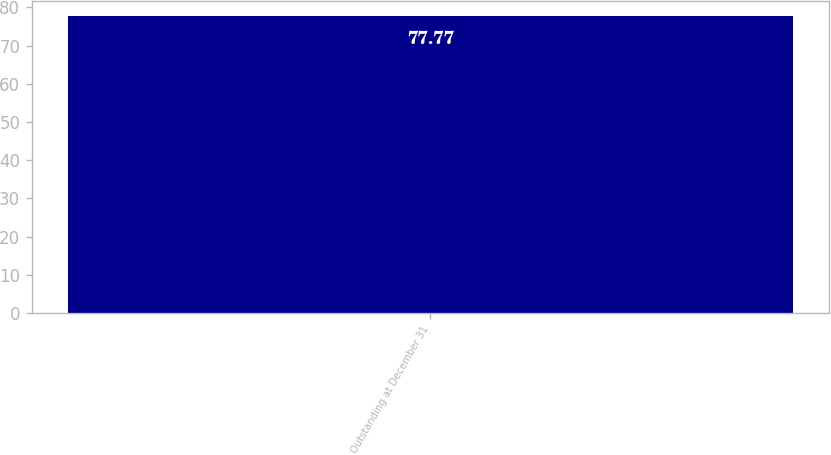Convert chart. <chart><loc_0><loc_0><loc_500><loc_500><bar_chart><fcel>Outstanding at December 31<nl><fcel>77.77<nl></chart> 